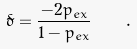<formula> <loc_0><loc_0><loc_500><loc_500>\tilde { \delta } = \frac { - 2 p _ { e x } } { 1 - p _ { e x } } \quad .</formula> 